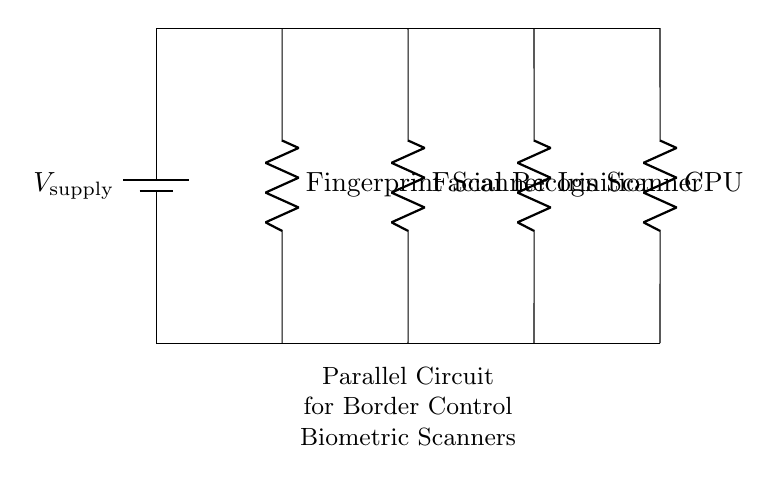What type of circuit is represented? The circuit is a parallel circuit, which can be determined by the arrangement where all biometric scanners are connected across the same voltage supply.
Answer: Parallel circuit How many biometric scanners are shown in the diagram? There are three biometric scanners drawn in the circuit, identified as the fingerprint scanner, facial recognition, and iris scanner.
Answer: Three What component primarily processes data from the biometric scanners? The CPU serves as the central processing unit that processes the data collected from the biometric scanners.
Answer: CPU What is the purpose of the battery in this circuit? The battery is the power supply, providing the necessary voltage to power all the devices connected in the circuit.
Answer: Power supply If one biometric scanner fails, what happens to the other scanners? The other scanners continue to operate since they are connected in parallel, allowing current to flow through the functional paths even if one is non-functional.
Answer: They continue to operate What is the significance of having a parallel arrangement for the scanners? A parallel arrangement allows each scanner to operate independently, ensuring that a failure in one does not affect the others, providing reliability to the border control system.
Answer: Reliability What is the voltage supplied to the biometric scanners? The voltage supplied is the same for all components in a parallel circuit, which is the voltage of the power supply indicated in the diagram.
Answer: V supply 